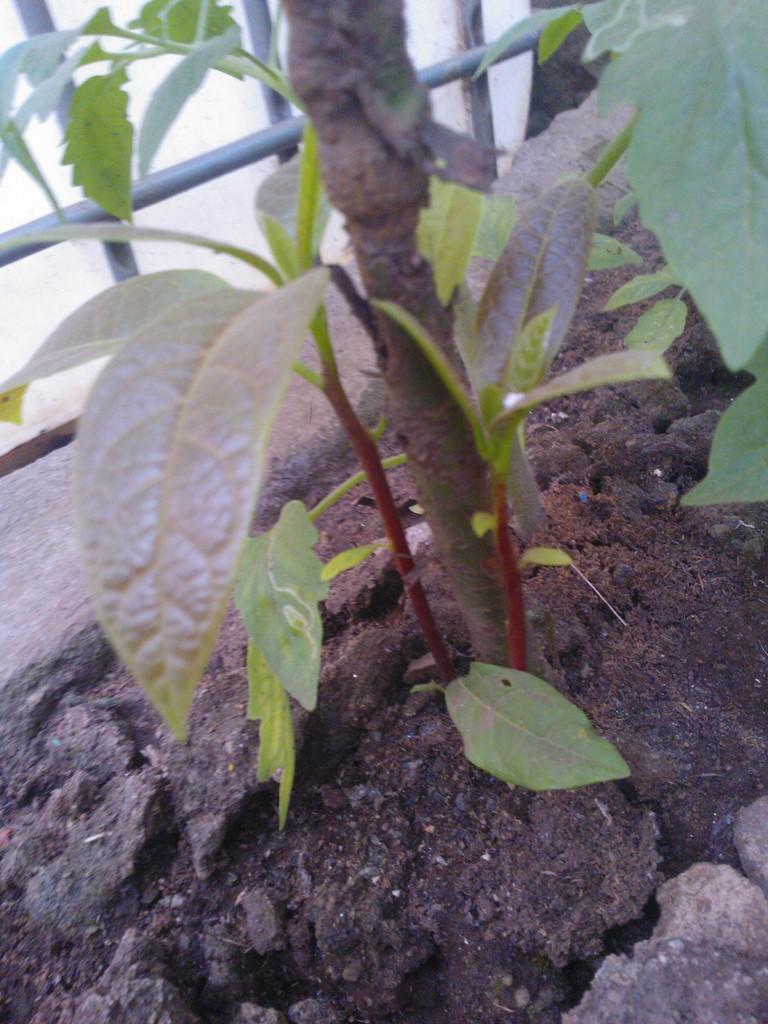How would you summarize this image in a sentence or two? In the image there is a plant and there are some rods in front of the plant. 